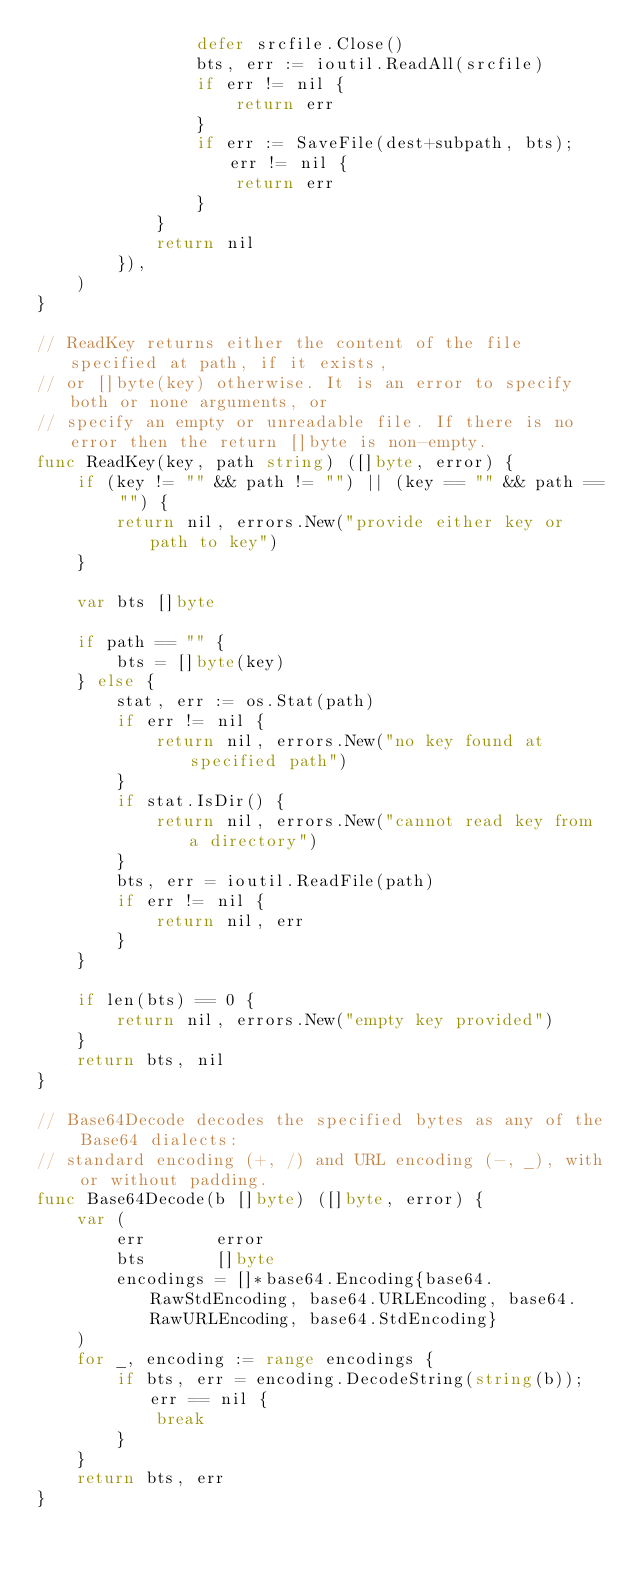Convert code to text. <code><loc_0><loc_0><loc_500><loc_500><_Go_>				defer srcfile.Close()
				bts, err := ioutil.ReadAll(srcfile)
				if err != nil {
					return err
				}
				if err := SaveFile(dest+subpath, bts); err != nil {
					return err
				}
			}
			return nil
		}),
	)
}

// ReadKey returns either the content of the file specified at path, if it exists,
// or []byte(key) otherwise. It is an error to specify both or none arguments, or
// specify an empty or unreadable file. If there is no error then the return []byte is non-empty.
func ReadKey(key, path string) ([]byte, error) {
	if (key != "" && path != "") || (key == "" && path == "") {
		return nil, errors.New("provide either key or path to key")
	}

	var bts []byte

	if path == "" {
		bts = []byte(key)
	} else {
		stat, err := os.Stat(path)
		if err != nil {
			return nil, errors.New("no key found at specified path")
		}
		if stat.IsDir() {
			return nil, errors.New("cannot read key from a directory")
		}
		bts, err = ioutil.ReadFile(path)
		if err != nil {
			return nil, err
		}
	}

	if len(bts) == 0 {
		return nil, errors.New("empty key provided")
	}
	return bts, nil
}

// Base64Decode decodes the specified bytes as any of the Base64 dialects:
// standard encoding (+, /) and URL encoding (-, _), with or without padding.
func Base64Decode(b []byte) ([]byte, error) {
	var (
		err       error
		bts       []byte
		encodings = []*base64.Encoding{base64.RawStdEncoding, base64.URLEncoding, base64.RawURLEncoding, base64.StdEncoding}
	)
	for _, encoding := range encodings {
		if bts, err = encoding.DecodeString(string(b)); err == nil {
			break
		}
	}
	return bts, err
}
</code> 